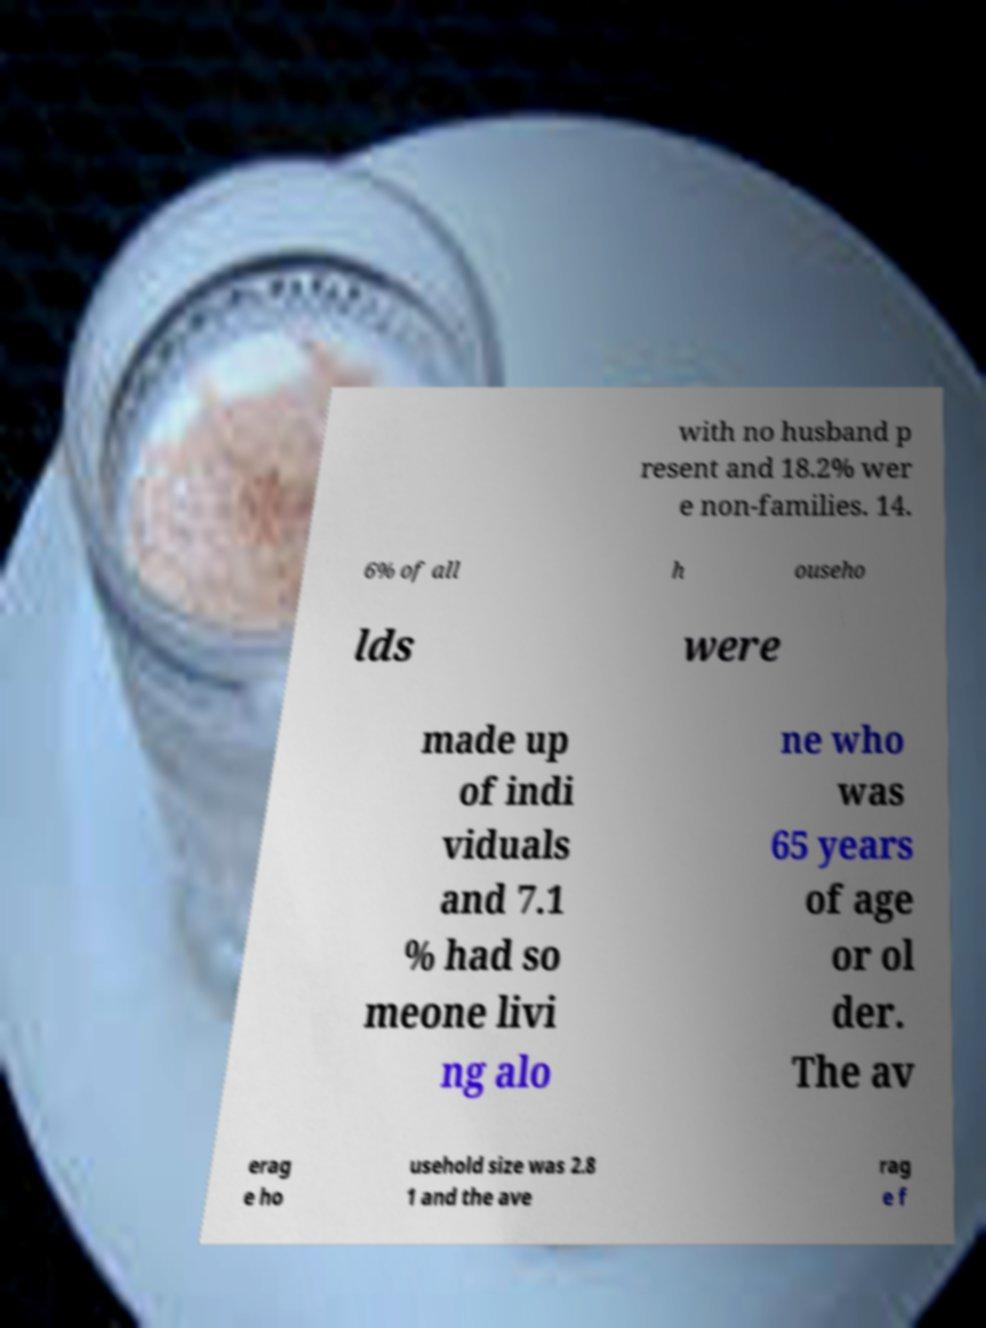Please read and relay the text visible in this image. What does it say? with no husband p resent and 18.2% wer e non-families. 14. 6% of all h ouseho lds were made up of indi viduals and 7.1 % had so meone livi ng alo ne who was 65 years of age or ol der. The av erag e ho usehold size was 2.8 1 and the ave rag e f 